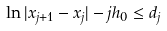<formula> <loc_0><loc_0><loc_500><loc_500>\ln | x _ { j + 1 } - x _ { j } | - j h _ { 0 } \leq d _ { j }</formula> 